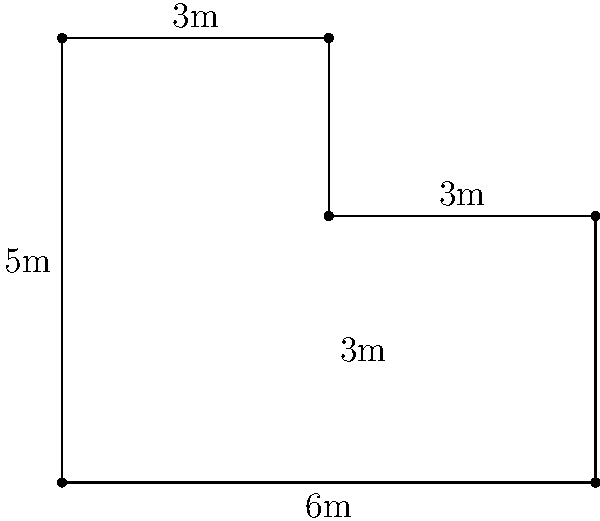In a historic home, you encounter an L-shaped room with the dimensions shown in the diagram. What is the total area of this room in square meters? To find the area of this L-shaped room, we can divide it into two rectangles and calculate their areas separately:

1. Rectangle 1 (left part):
   Width = 3m
   Height = 5m
   Area of Rectangle 1 = $3m \times 5m = 15m^2$

2. Rectangle 2 (right part):
   Width = 3m
   Height = 3m
   Area of Rectangle 2 = $3m \times 3m = 9m^2$

3. Total area:
   Add the areas of both rectangles
   Total Area = Area of Rectangle 1 + Area of Rectangle 2
   Total Area = $15m^2 + 9m^2 = 24m^2$

Therefore, the total area of the L-shaped room is 24 square meters.
Answer: $24m^2$ 